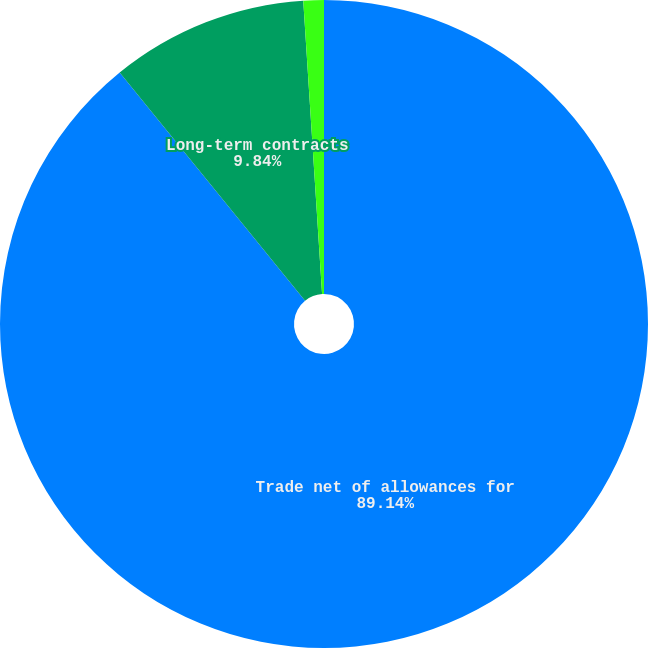<chart> <loc_0><loc_0><loc_500><loc_500><pie_chart><fcel>Trade net of allowances for<fcel>Long-term contracts<fcel>Other<nl><fcel>89.14%<fcel>9.84%<fcel>1.02%<nl></chart> 